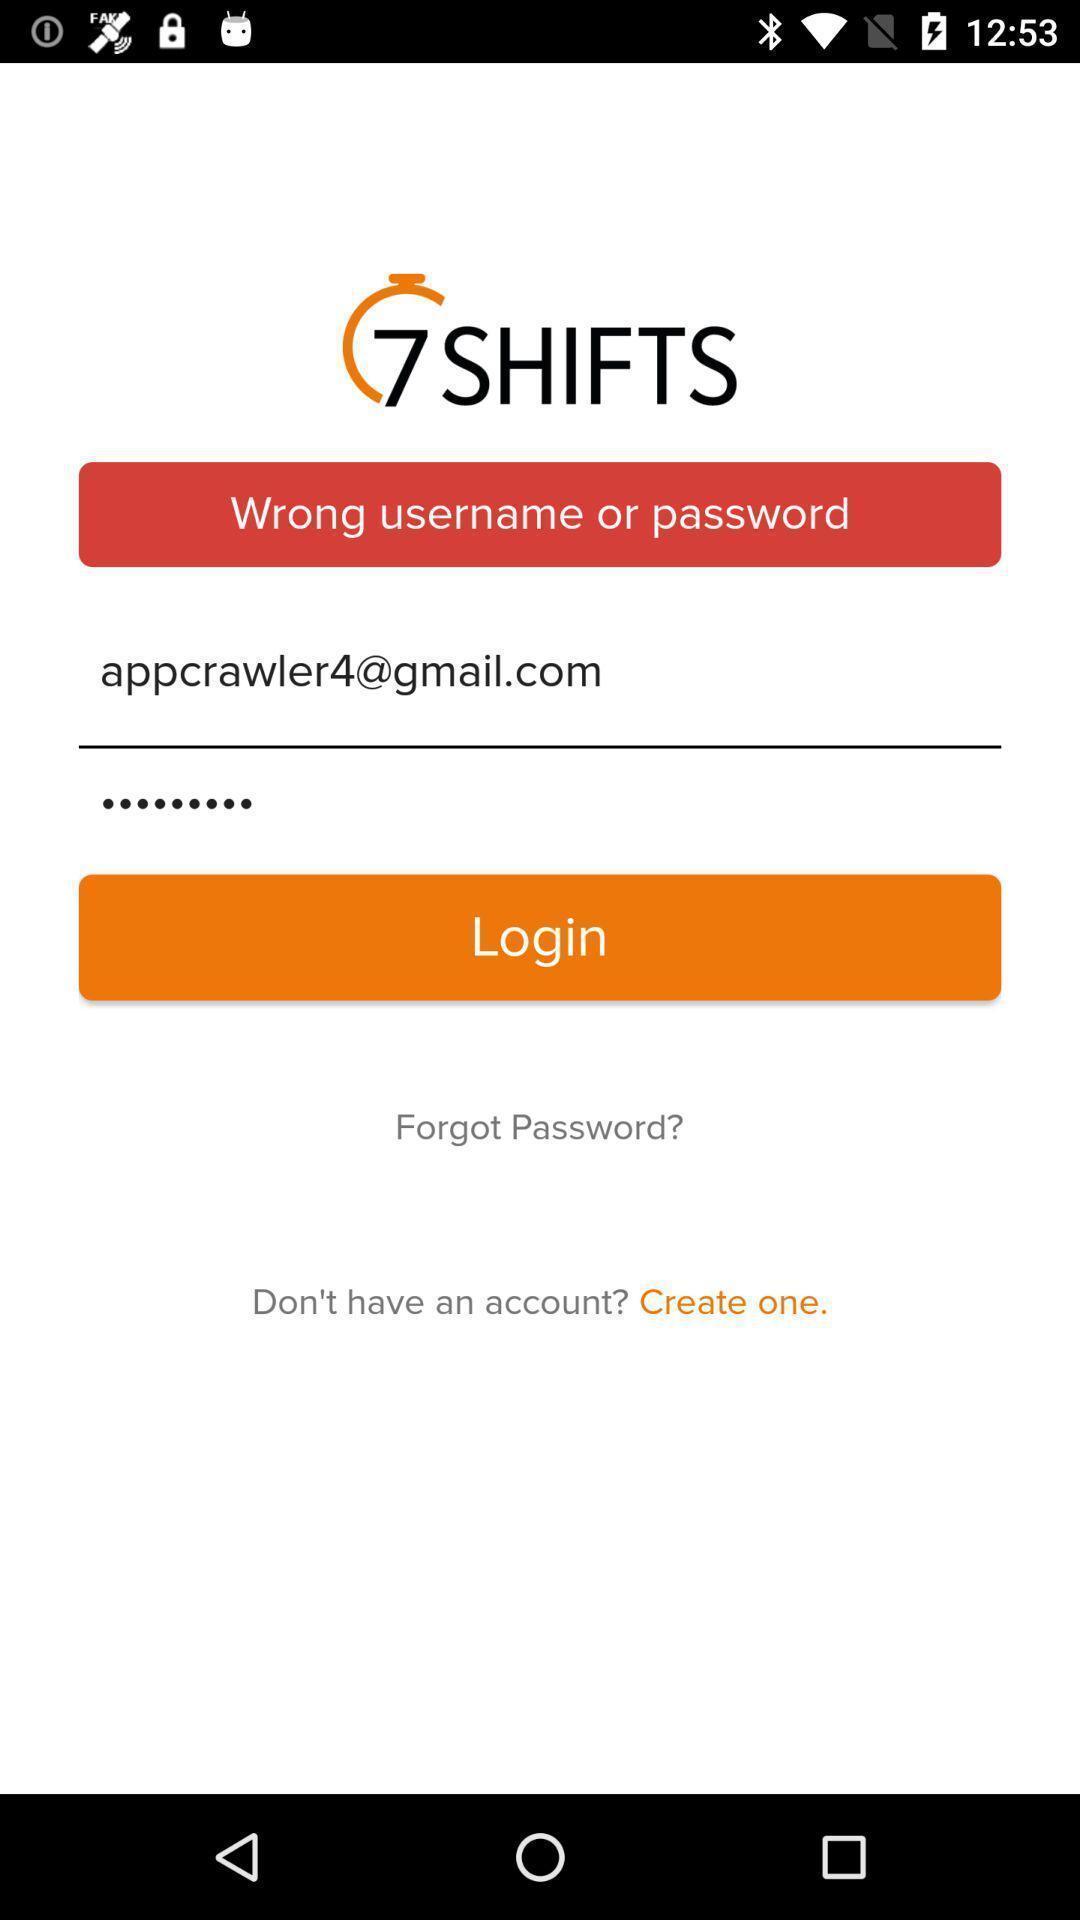Give me a narrative description of this picture. Login page of an account. 